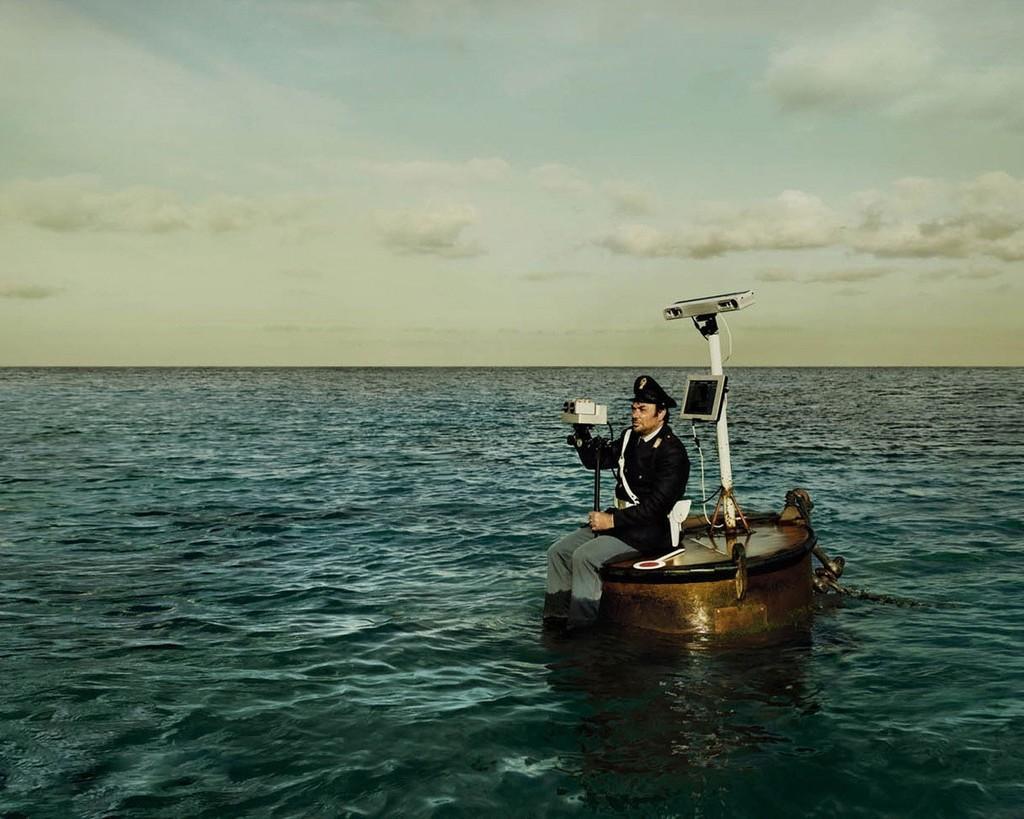Describe this image in one or two sentences. In this image we can see a person sitting in a boat travelling in water holding a compass. We can also see a monitor, camera and a chain in the boat. On the backside we can see the sky which looks cloudy. 